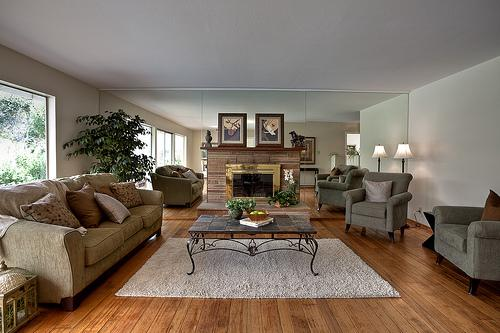Question: who is on the couch?
Choices:
A. Nobody.
B. Baby.
C. Woman.
D. Couple.
Answer with the letter. Answer: A Question: where was the couch?
Choices:
A. Next to the fireplace.
B. Against the white wall.
C. In the middle of the room.
D. In front of the window.
Answer with the letter. Answer: D Question: what is the floor made of?
Choices:
A. Carpet.
B. Concrete.
C. Tile.
D. Wood.
Answer with the letter. Answer: D Question: how many chairs?
Choices:
A. 5.
B. 8.
C. 2.
D. 9.
Answer with the letter. Answer: C Question: why is there a reflection?
Choices:
A. A water puddle.
B. A lake.
C. A clean window.
D. A mirror.
Answer with the letter. Answer: D Question: what is on the floor?
Choices:
A. Socks and shoes.
B. Dust bunnies.
C. Dog toys.
D. A rug.
Answer with the letter. Answer: D 